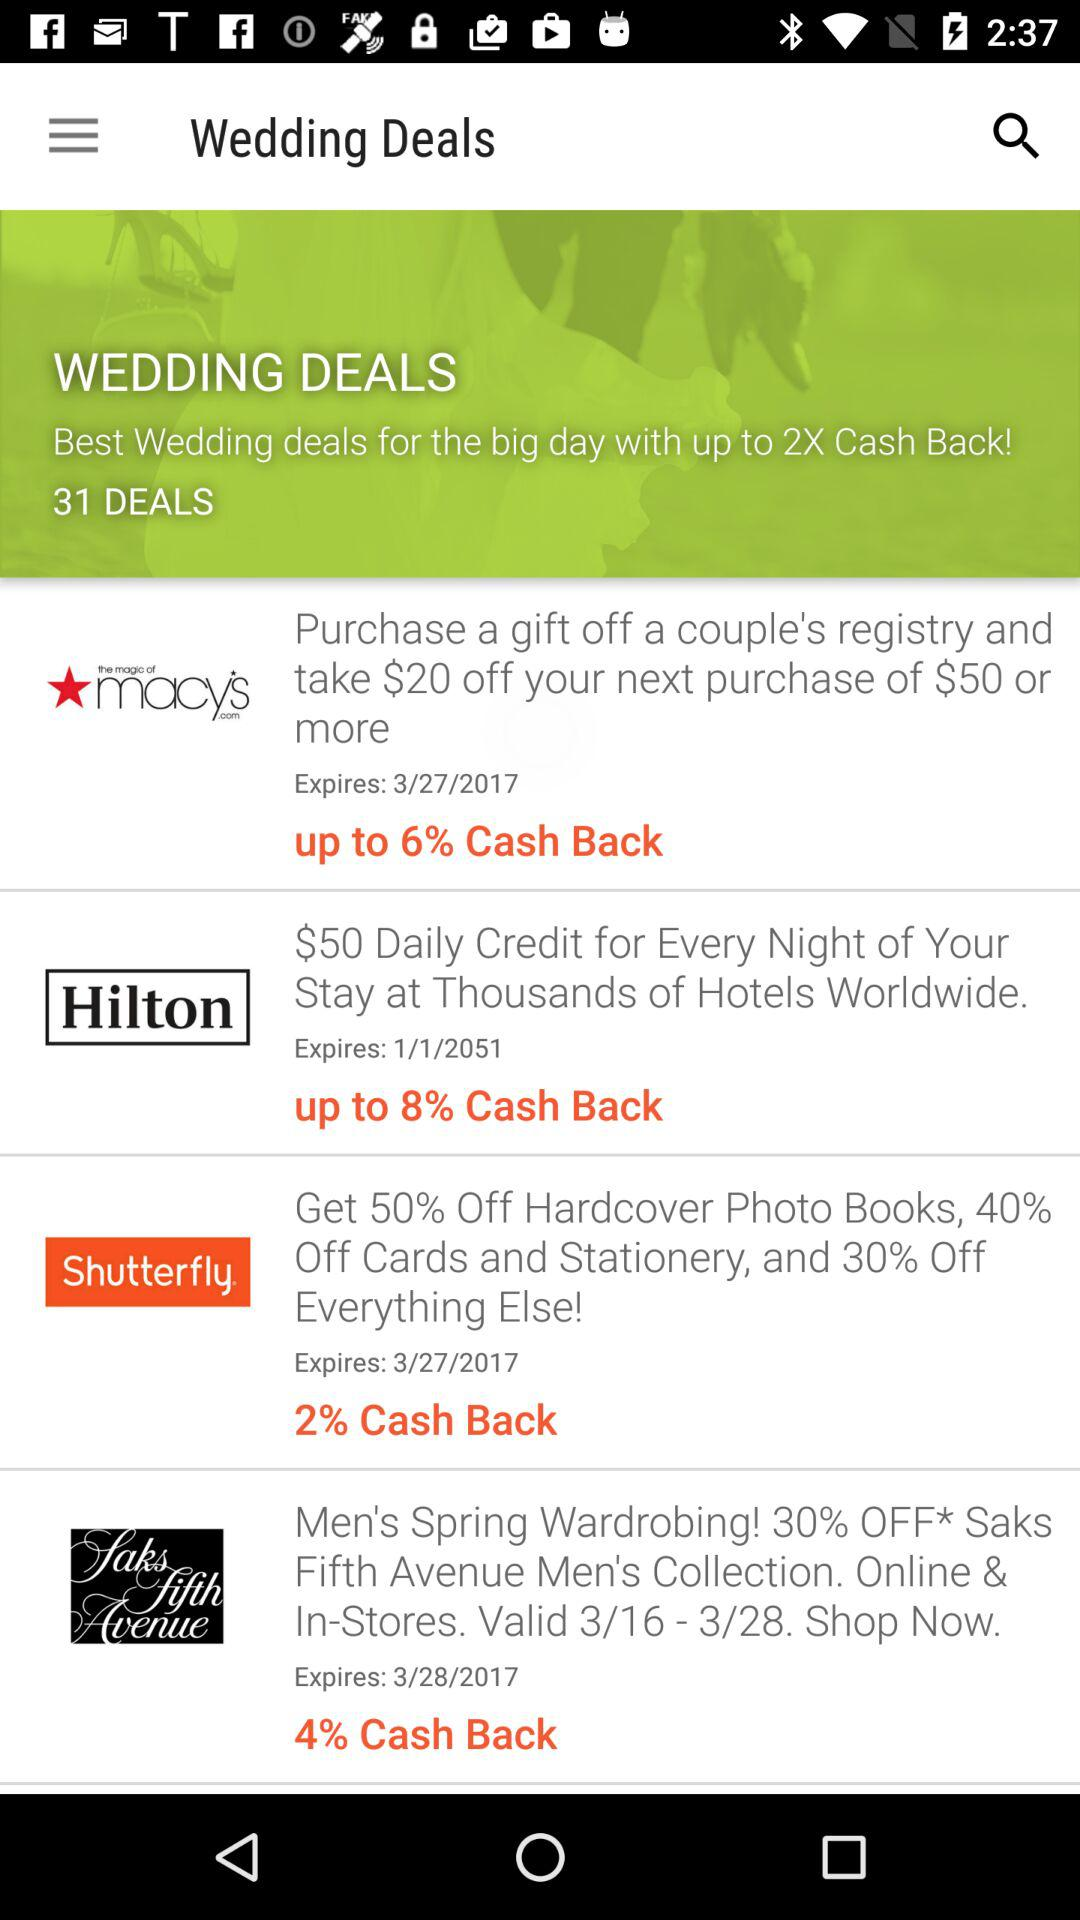How many deals in total are there? There are 31 deals in total. 